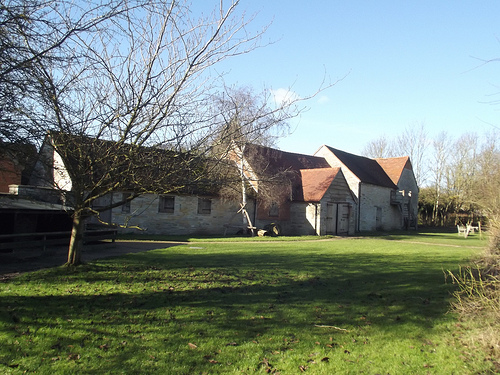<image>
Is the tree to the right of the house? No. The tree is not to the right of the house. The horizontal positioning shows a different relationship. 